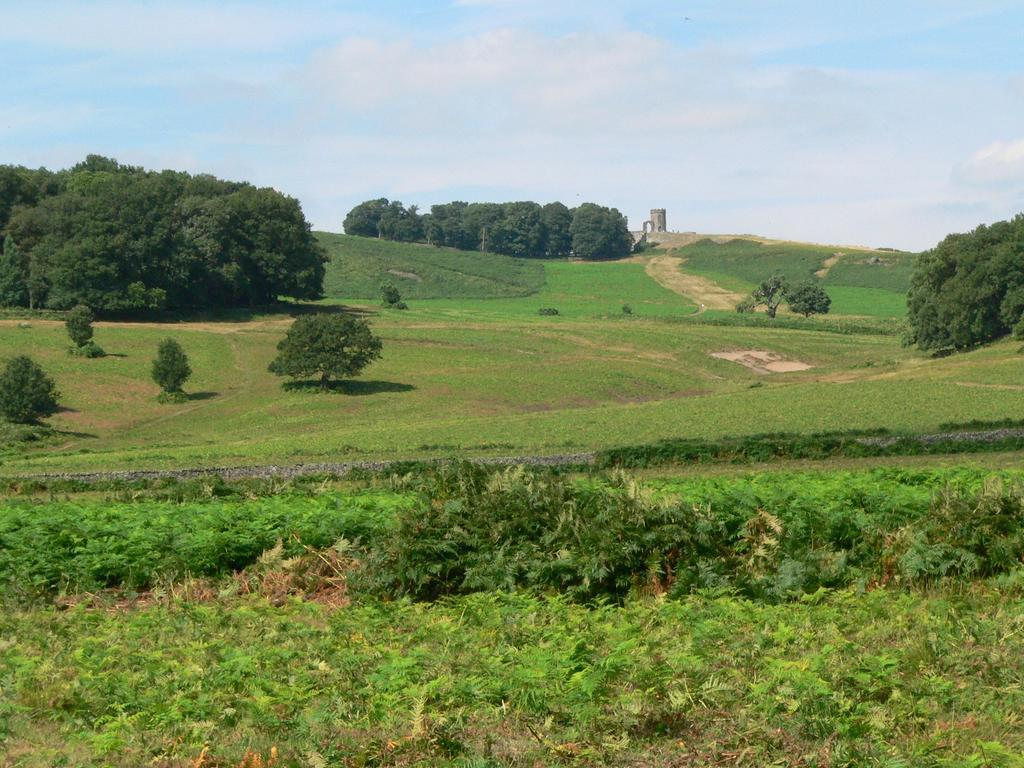What type of vegetation can be seen in the image? There are plants, grass, and trees visible in the image. What is the surface on which the vegetation is growing? The ground is visible in the image. What can be seen in the sky in the background of the image? There are clouds in the sky in the background of the image. What hobbies do the plants in the image enjoy? Plants do not have hobbies, as they are living organisms and not capable of engaging in hobbies. 